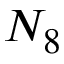<formula> <loc_0><loc_0><loc_500><loc_500>N _ { 8 }</formula> 